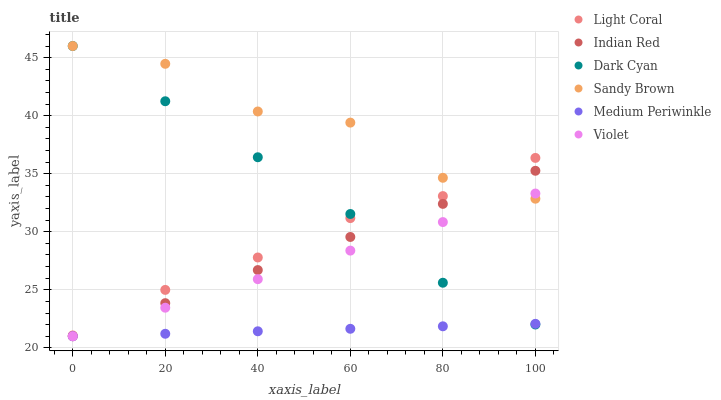Does Medium Periwinkle have the minimum area under the curve?
Answer yes or no. Yes. Does Sandy Brown have the maximum area under the curve?
Answer yes or no. Yes. Does Light Coral have the minimum area under the curve?
Answer yes or no. No. Does Light Coral have the maximum area under the curve?
Answer yes or no. No. Is Indian Red the smoothest?
Answer yes or no. Yes. Is Sandy Brown the roughest?
Answer yes or no. Yes. Is Light Coral the smoothest?
Answer yes or no. No. Is Light Coral the roughest?
Answer yes or no. No. Does Medium Periwinkle have the lowest value?
Answer yes or no. Yes. Does Light Coral have the lowest value?
Answer yes or no. No. Does Sandy Brown have the highest value?
Answer yes or no. Yes. Does Light Coral have the highest value?
Answer yes or no. No. Is Medium Periwinkle less than Sandy Brown?
Answer yes or no. Yes. Is Sandy Brown greater than Medium Periwinkle?
Answer yes or no. Yes. Does Violet intersect Medium Periwinkle?
Answer yes or no. Yes. Is Violet less than Medium Periwinkle?
Answer yes or no. No. Is Violet greater than Medium Periwinkle?
Answer yes or no. No. Does Medium Periwinkle intersect Sandy Brown?
Answer yes or no. No. 